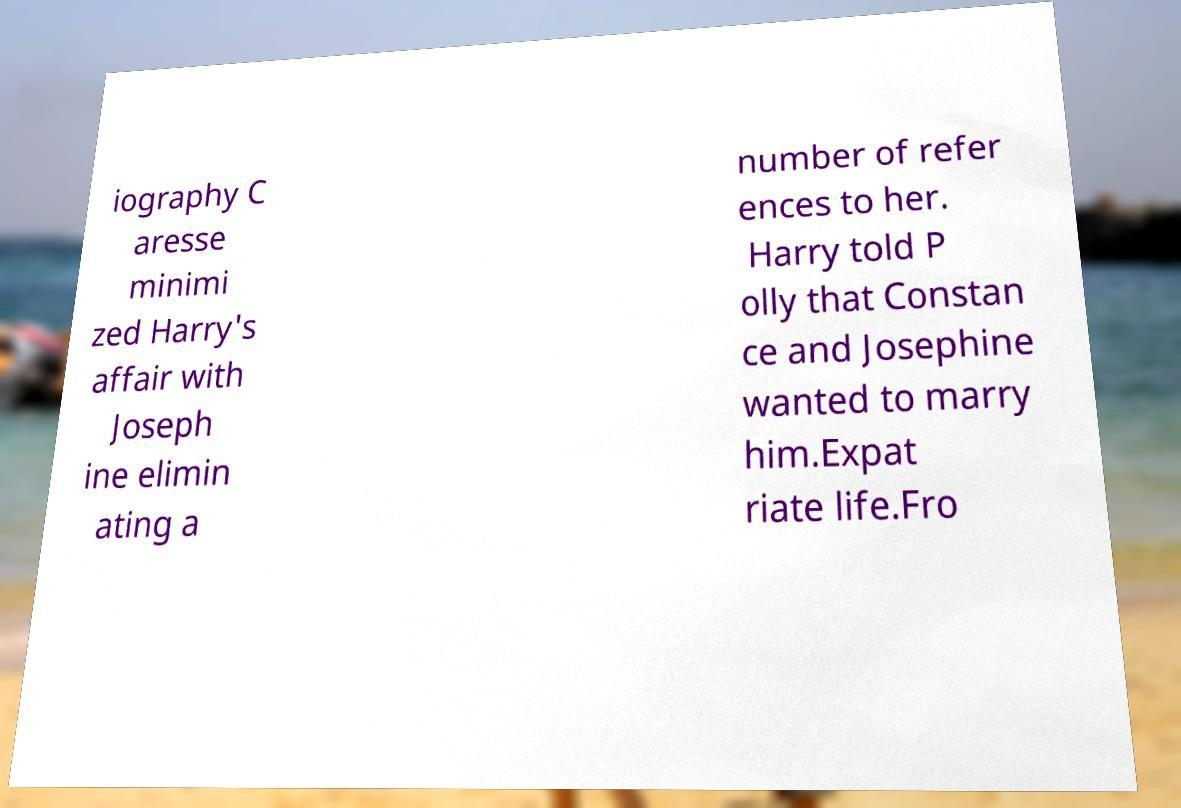Could you extract and type out the text from this image? iography C aresse minimi zed Harry's affair with Joseph ine elimin ating a number of refer ences to her. Harry told P olly that Constan ce and Josephine wanted to marry him.Expat riate life.Fro 